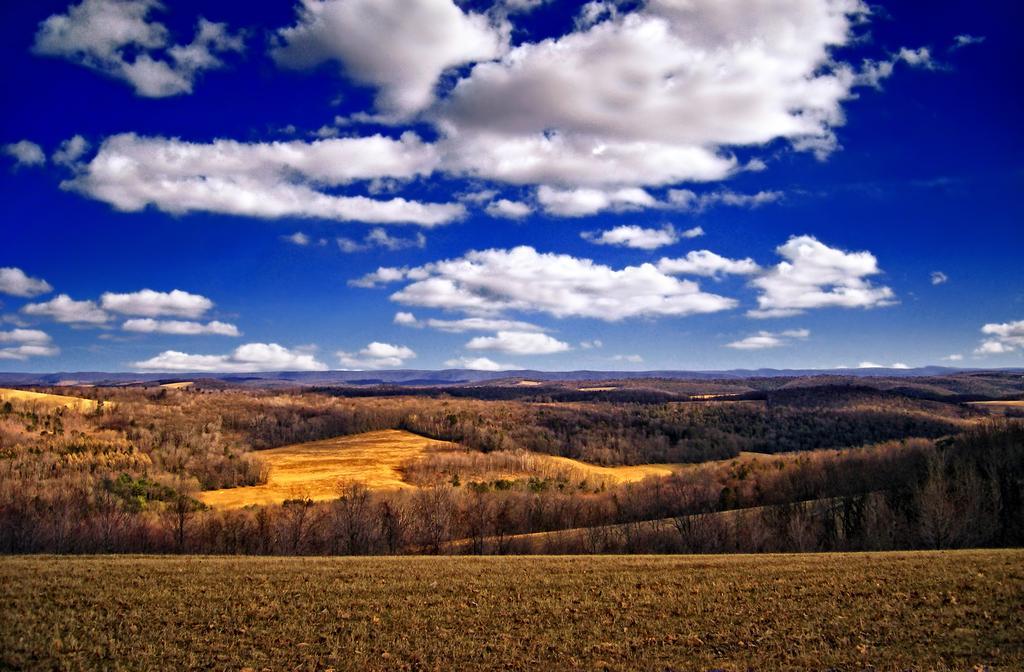Please provide a concise description of this image. In this image we can see many trees and plants. There is a blue and a slightly cloudy sky in the image. 